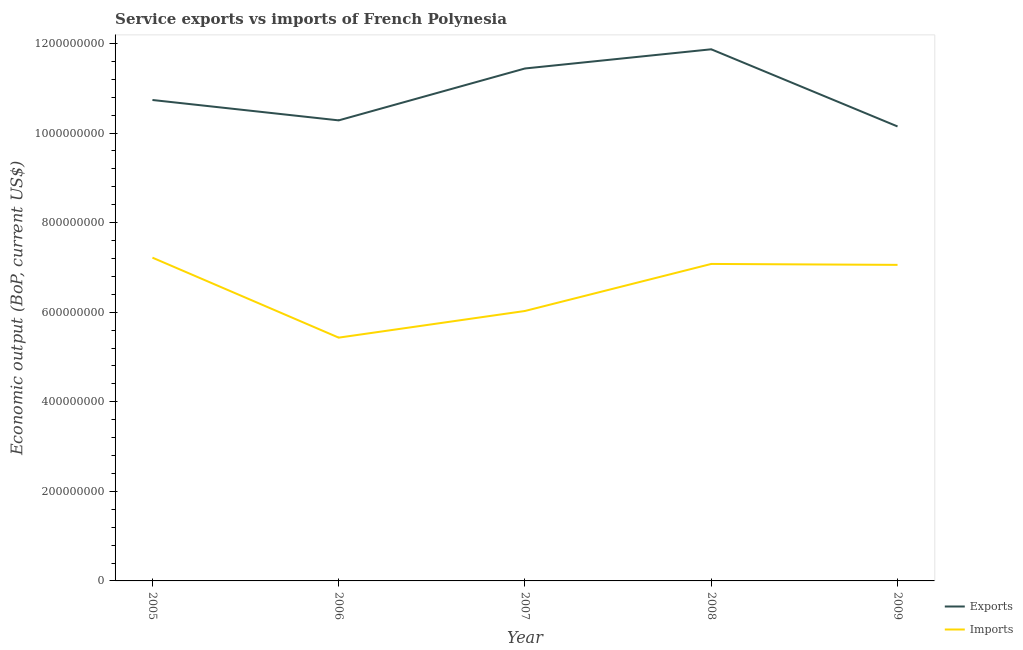Does the line corresponding to amount of service imports intersect with the line corresponding to amount of service exports?
Keep it short and to the point. No. Is the number of lines equal to the number of legend labels?
Make the answer very short. Yes. What is the amount of service imports in 2007?
Offer a very short reply. 6.03e+08. Across all years, what is the maximum amount of service exports?
Offer a terse response. 1.19e+09. Across all years, what is the minimum amount of service exports?
Provide a short and direct response. 1.01e+09. In which year was the amount of service exports minimum?
Make the answer very short. 2009. What is the total amount of service imports in the graph?
Offer a very short reply. 3.28e+09. What is the difference between the amount of service imports in 2008 and that in 2009?
Your answer should be very brief. 2.12e+06. What is the difference between the amount of service exports in 2007 and the amount of service imports in 2006?
Provide a succinct answer. 6.01e+08. What is the average amount of service imports per year?
Provide a succinct answer. 6.56e+08. In the year 2008, what is the difference between the amount of service exports and amount of service imports?
Offer a terse response. 4.79e+08. In how many years, is the amount of service exports greater than 1120000000 US$?
Ensure brevity in your answer.  2. What is the ratio of the amount of service imports in 2007 to that in 2009?
Offer a terse response. 0.85. Is the amount of service exports in 2007 less than that in 2009?
Your answer should be very brief. No. Is the difference between the amount of service exports in 2006 and 2008 greater than the difference between the amount of service imports in 2006 and 2008?
Offer a very short reply. Yes. What is the difference between the highest and the second highest amount of service exports?
Keep it short and to the point. 4.28e+07. What is the difference between the highest and the lowest amount of service imports?
Provide a short and direct response. 1.79e+08. Is the amount of service exports strictly greater than the amount of service imports over the years?
Keep it short and to the point. Yes. Is the amount of service exports strictly less than the amount of service imports over the years?
Provide a succinct answer. No. How many lines are there?
Offer a terse response. 2. Are the values on the major ticks of Y-axis written in scientific E-notation?
Your answer should be compact. No. Does the graph contain grids?
Your response must be concise. No. Where does the legend appear in the graph?
Ensure brevity in your answer.  Bottom right. What is the title of the graph?
Offer a terse response. Service exports vs imports of French Polynesia. Does "Excluding technical cooperation" appear as one of the legend labels in the graph?
Make the answer very short. No. What is the label or title of the X-axis?
Keep it short and to the point. Year. What is the label or title of the Y-axis?
Your answer should be compact. Economic output (BoP, current US$). What is the Economic output (BoP, current US$) of Exports in 2005?
Offer a terse response. 1.07e+09. What is the Economic output (BoP, current US$) of Imports in 2005?
Make the answer very short. 7.22e+08. What is the Economic output (BoP, current US$) of Exports in 2006?
Make the answer very short. 1.03e+09. What is the Economic output (BoP, current US$) in Imports in 2006?
Offer a terse response. 5.43e+08. What is the Economic output (BoP, current US$) of Exports in 2007?
Give a very brief answer. 1.14e+09. What is the Economic output (BoP, current US$) of Imports in 2007?
Your response must be concise. 6.03e+08. What is the Economic output (BoP, current US$) in Exports in 2008?
Offer a terse response. 1.19e+09. What is the Economic output (BoP, current US$) of Imports in 2008?
Offer a terse response. 7.08e+08. What is the Economic output (BoP, current US$) of Exports in 2009?
Offer a terse response. 1.01e+09. What is the Economic output (BoP, current US$) of Imports in 2009?
Provide a succinct answer. 7.06e+08. Across all years, what is the maximum Economic output (BoP, current US$) of Exports?
Make the answer very short. 1.19e+09. Across all years, what is the maximum Economic output (BoP, current US$) in Imports?
Your answer should be very brief. 7.22e+08. Across all years, what is the minimum Economic output (BoP, current US$) of Exports?
Your answer should be compact. 1.01e+09. Across all years, what is the minimum Economic output (BoP, current US$) in Imports?
Make the answer very short. 5.43e+08. What is the total Economic output (BoP, current US$) in Exports in the graph?
Keep it short and to the point. 5.45e+09. What is the total Economic output (BoP, current US$) of Imports in the graph?
Ensure brevity in your answer.  3.28e+09. What is the difference between the Economic output (BoP, current US$) of Exports in 2005 and that in 2006?
Your answer should be very brief. 4.55e+07. What is the difference between the Economic output (BoP, current US$) in Imports in 2005 and that in 2006?
Keep it short and to the point. 1.79e+08. What is the difference between the Economic output (BoP, current US$) in Exports in 2005 and that in 2007?
Offer a terse response. -7.04e+07. What is the difference between the Economic output (BoP, current US$) in Imports in 2005 and that in 2007?
Give a very brief answer. 1.19e+08. What is the difference between the Economic output (BoP, current US$) of Exports in 2005 and that in 2008?
Your response must be concise. -1.13e+08. What is the difference between the Economic output (BoP, current US$) of Imports in 2005 and that in 2008?
Give a very brief answer. 1.40e+07. What is the difference between the Economic output (BoP, current US$) of Exports in 2005 and that in 2009?
Give a very brief answer. 5.91e+07. What is the difference between the Economic output (BoP, current US$) in Imports in 2005 and that in 2009?
Your response must be concise. 1.61e+07. What is the difference between the Economic output (BoP, current US$) of Exports in 2006 and that in 2007?
Offer a very short reply. -1.16e+08. What is the difference between the Economic output (BoP, current US$) in Imports in 2006 and that in 2007?
Make the answer very short. -5.95e+07. What is the difference between the Economic output (BoP, current US$) of Exports in 2006 and that in 2008?
Give a very brief answer. -1.59e+08. What is the difference between the Economic output (BoP, current US$) of Imports in 2006 and that in 2008?
Your answer should be very brief. -1.65e+08. What is the difference between the Economic output (BoP, current US$) in Exports in 2006 and that in 2009?
Your answer should be compact. 1.36e+07. What is the difference between the Economic output (BoP, current US$) of Imports in 2006 and that in 2009?
Your answer should be compact. -1.62e+08. What is the difference between the Economic output (BoP, current US$) in Exports in 2007 and that in 2008?
Keep it short and to the point. -4.28e+07. What is the difference between the Economic output (BoP, current US$) of Imports in 2007 and that in 2008?
Your answer should be very brief. -1.05e+08. What is the difference between the Economic output (BoP, current US$) in Exports in 2007 and that in 2009?
Ensure brevity in your answer.  1.29e+08. What is the difference between the Economic output (BoP, current US$) of Imports in 2007 and that in 2009?
Offer a terse response. -1.03e+08. What is the difference between the Economic output (BoP, current US$) in Exports in 2008 and that in 2009?
Provide a succinct answer. 1.72e+08. What is the difference between the Economic output (BoP, current US$) in Imports in 2008 and that in 2009?
Your response must be concise. 2.12e+06. What is the difference between the Economic output (BoP, current US$) in Exports in 2005 and the Economic output (BoP, current US$) in Imports in 2006?
Your response must be concise. 5.31e+08. What is the difference between the Economic output (BoP, current US$) of Exports in 2005 and the Economic output (BoP, current US$) of Imports in 2007?
Your answer should be very brief. 4.71e+08. What is the difference between the Economic output (BoP, current US$) in Exports in 2005 and the Economic output (BoP, current US$) in Imports in 2008?
Your response must be concise. 3.66e+08. What is the difference between the Economic output (BoP, current US$) of Exports in 2005 and the Economic output (BoP, current US$) of Imports in 2009?
Your response must be concise. 3.68e+08. What is the difference between the Economic output (BoP, current US$) in Exports in 2006 and the Economic output (BoP, current US$) in Imports in 2007?
Your answer should be compact. 4.26e+08. What is the difference between the Economic output (BoP, current US$) of Exports in 2006 and the Economic output (BoP, current US$) of Imports in 2008?
Your answer should be compact. 3.21e+08. What is the difference between the Economic output (BoP, current US$) in Exports in 2006 and the Economic output (BoP, current US$) in Imports in 2009?
Keep it short and to the point. 3.23e+08. What is the difference between the Economic output (BoP, current US$) of Exports in 2007 and the Economic output (BoP, current US$) of Imports in 2008?
Keep it short and to the point. 4.36e+08. What is the difference between the Economic output (BoP, current US$) in Exports in 2007 and the Economic output (BoP, current US$) in Imports in 2009?
Provide a short and direct response. 4.39e+08. What is the difference between the Economic output (BoP, current US$) of Exports in 2008 and the Economic output (BoP, current US$) of Imports in 2009?
Ensure brevity in your answer.  4.81e+08. What is the average Economic output (BoP, current US$) in Exports per year?
Provide a succinct answer. 1.09e+09. What is the average Economic output (BoP, current US$) of Imports per year?
Offer a very short reply. 6.56e+08. In the year 2005, what is the difference between the Economic output (BoP, current US$) of Exports and Economic output (BoP, current US$) of Imports?
Your answer should be very brief. 3.52e+08. In the year 2006, what is the difference between the Economic output (BoP, current US$) of Exports and Economic output (BoP, current US$) of Imports?
Provide a succinct answer. 4.85e+08. In the year 2007, what is the difference between the Economic output (BoP, current US$) in Exports and Economic output (BoP, current US$) in Imports?
Give a very brief answer. 5.41e+08. In the year 2008, what is the difference between the Economic output (BoP, current US$) of Exports and Economic output (BoP, current US$) of Imports?
Ensure brevity in your answer.  4.79e+08. In the year 2009, what is the difference between the Economic output (BoP, current US$) in Exports and Economic output (BoP, current US$) in Imports?
Provide a succinct answer. 3.09e+08. What is the ratio of the Economic output (BoP, current US$) in Exports in 2005 to that in 2006?
Give a very brief answer. 1.04. What is the ratio of the Economic output (BoP, current US$) of Imports in 2005 to that in 2006?
Offer a very short reply. 1.33. What is the ratio of the Economic output (BoP, current US$) of Exports in 2005 to that in 2007?
Make the answer very short. 0.94. What is the ratio of the Economic output (BoP, current US$) in Imports in 2005 to that in 2007?
Give a very brief answer. 1.2. What is the ratio of the Economic output (BoP, current US$) in Exports in 2005 to that in 2008?
Ensure brevity in your answer.  0.9. What is the ratio of the Economic output (BoP, current US$) in Imports in 2005 to that in 2008?
Give a very brief answer. 1.02. What is the ratio of the Economic output (BoP, current US$) of Exports in 2005 to that in 2009?
Offer a very short reply. 1.06. What is the ratio of the Economic output (BoP, current US$) of Imports in 2005 to that in 2009?
Your answer should be compact. 1.02. What is the ratio of the Economic output (BoP, current US$) of Exports in 2006 to that in 2007?
Your answer should be compact. 0.9. What is the ratio of the Economic output (BoP, current US$) in Imports in 2006 to that in 2007?
Keep it short and to the point. 0.9. What is the ratio of the Economic output (BoP, current US$) in Exports in 2006 to that in 2008?
Offer a terse response. 0.87. What is the ratio of the Economic output (BoP, current US$) of Imports in 2006 to that in 2008?
Your answer should be very brief. 0.77. What is the ratio of the Economic output (BoP, current US$) in Exports in 2006 to that in 2009?
Provide a succinct answer. 1.01. What is the ratio of the Economic output (BoP, current US$) of Imports in 2006 to that in 2009?
Offer a very short reply. 0.77. What is the ratio of the Economic output (BoP, current US$) of Exports in 2007 to that in 2008?
Your answer should be very brief. 0.96. What is the ratio of the Economic output (BoP, current US$) of Imports in 2007 to that in 2008?
Provide a succinct answer. 0.85. What is the ratio of the Economic output (BoP, current US$) in Exports in 2007 to that in 2009?
Give a very brief answer. 1.13. What is the ratio of the Economic output (BoP, current US$) in Imports in 2007 to that in 2009?
Make the answer very short. 0.85. What is the ratio of the Economic output (BoP, current US$) in Exports in 2008 to that in 2009?
Your answer should be compact. 1.17. What is the ratio of the Economic output (BoP, current US$) in Imports in 2008 to that in 2009?
Keep it short and to the point. 1. What is the difference between the highest and the second highest Economic output (BoP, current US$) in Exports?
Your answer should be very brief. 4.28e+07. What is the difference between the highest and the second highest Economic output (BoP, current US$) of Imports?
Offer a very short reply. 1.40e+07. What is the difference between the highest and the lowest Economic output (BoP, current US$) in Exports?
Your answer should be compact. 1.72e+08. What is the difference between the highest and the lowest Economic output (BoP, current US$) in Imports?
Your answer should be compact. 1.79e+08. 